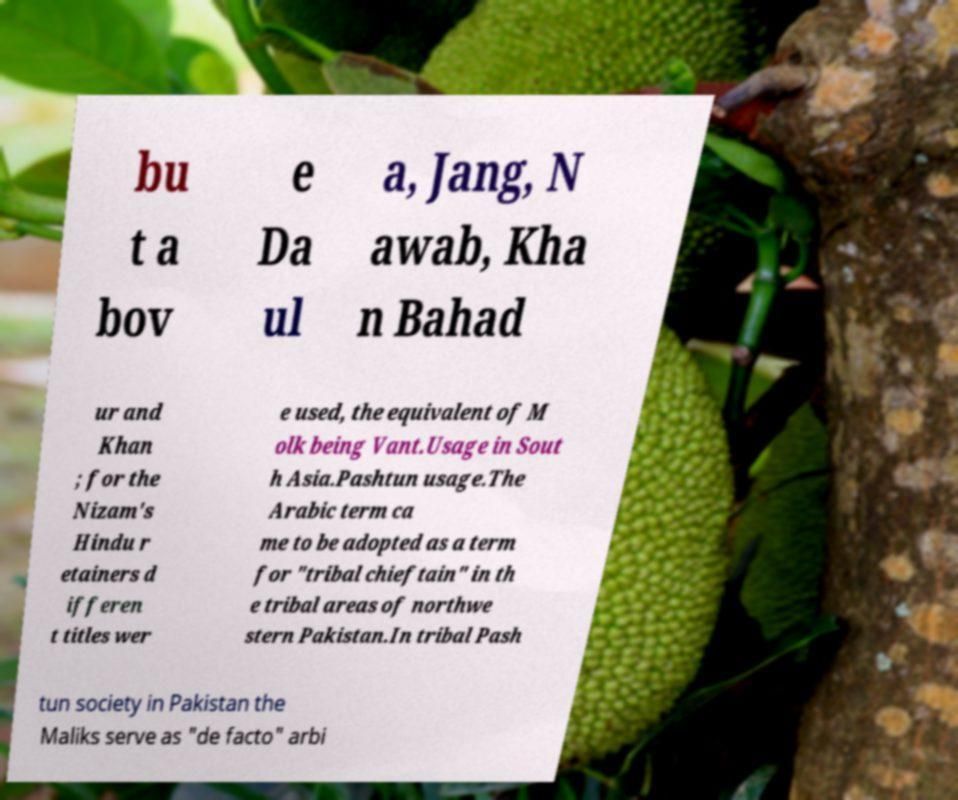For documentation purposes, I need the text within this image transcribed. Could you provide that? bu t a bov e Da ul a, Jang, N awab, Kha n Bahad ur and Khan ; for the Nizam's Hindu r etainers d ifferen t titles wer e used, the equivalent of M olk being Vant.Usage in Sout h Asia.Pashtun usage.The Arabic term ca me to be adopted as a term for "tribal chieftain" in th e tribal areas of northwe stern Pakistan.In tribal Pash tun society in Pakistan the Maliks serve as "de facto" arbi 